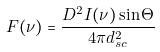Convert formula to latex. <formula><loc_0><loc_0><loc_500><loc_500>F ( \nu ) = \frac { D ^ { 2 } I ( \nu ) \sin \Theta } { 4 \pi d _ { s c } ^ { 2 } }</formula> 